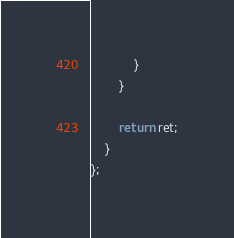Convert code to text. <code><loc_0><loc_0><loc_500><loc_500><_C++_>            }           
        }

        return ret;
    }
};

</code> 